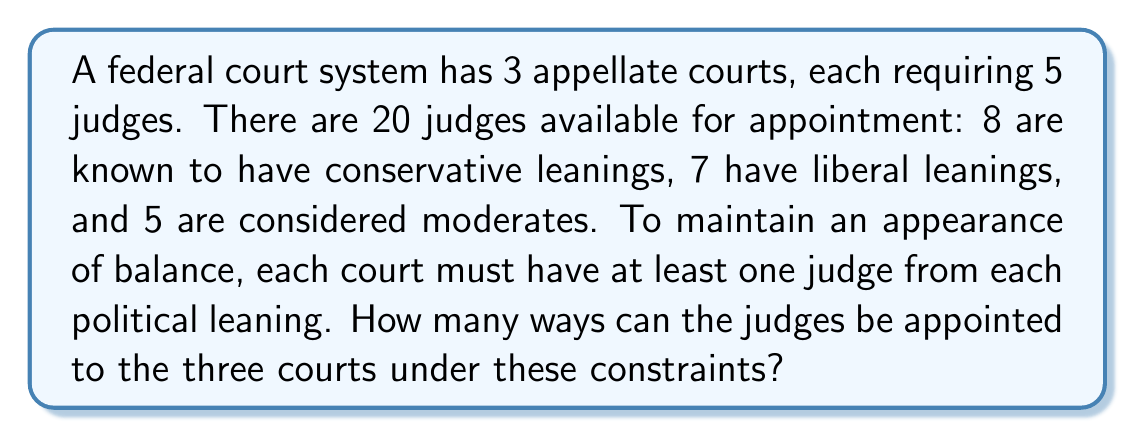Provide a solution to this math problem. Let's approach this step-by-step:

1) First, we need to ensure each court has at least one judge from each political leaning. We can do this by distributing one judge of each leaning to each court:

   - 3 conservative judges (one for each court)
   - 3 liberal judges (one for each court)
   - 3 moderate judges (one for each court)

2) This leaves us with:

   - 5 conservative judges
   - 4 liberal judges
   - 2 moderate judges

   And 6 positions left to fill (2 in each court).

3) Now, we need to distribute these remaining judges. This is a problem of distributing distinguishable objects (judges) into distinguishable boxes (courts).

4) We can use the multinomial theorem. The number of ways to distribute $n$ distinguishable objects into $k$ distinguishable boxes, with $n_i$ objects in the $i$-th box, is:

   $$\frac{n!}{n_1!n_2!...n_k!}$$

5) In our case, $n = 11$ (remaining judges), $k = 3$ (courts), and $n_1 = n_2 = n_3 = 2$ (each court needs 2 more judges).

6) So, the number of ways to distribute the remaining judges is:

   $$\frac{11!}{2!2!2!5!} = 207,900$$

7) However, this counts all possible distributions. We need to multiply this by the number of ways to choose which 5 out of 8 conservative judges, 4 out of 7 liberal judges, and 2 out of 5 moderate judges will be in these remaining positions.

8) This is given by:

   $$\binom{8}{5} \cdot \binom{7}{4} \cdot \binom{5}{2} = 56 \cdot 35 \cdot 10 = 19,600$$

9) The total number of ways is the product of steps 6 and 8:

   $$207,900 \cdot 19,600 = 4,074,840,000$$
Answer: $4,074,840,000$ 